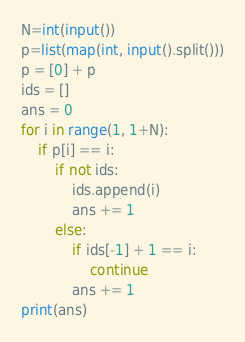<code> <loc_0><loc_0><loc_500><loc_500><_Python_>N=int(input())
p=list(map(int, input().split()))
p = [0] + p
ids = []
ans = 0
for i in range(1, 1+N):
    if p[i] == i:
        if not ids:
            ids.append(i)
            ans += 1
        else:
            if ids[-1] + 1 == i:
                continue
            ans += 1
print(ans) </code> 